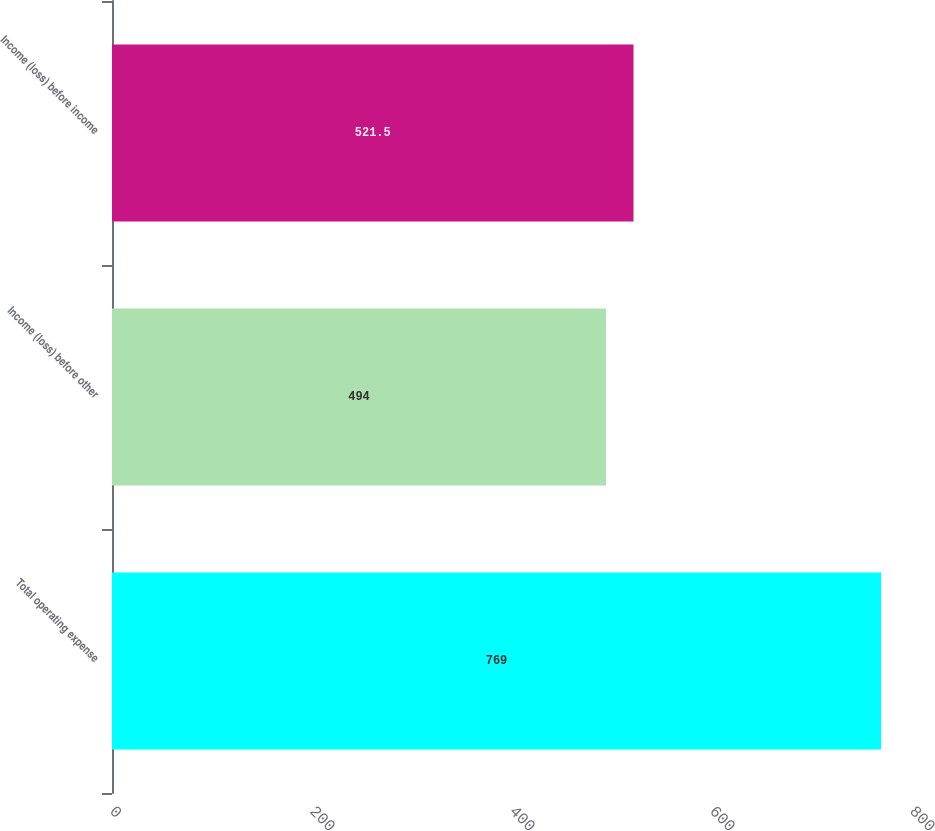<chart> <loc_0><loc_0><loc_500><loc_500><bar_chart><fcel>Total operating expense<fcel>Income (loss) before other<fcel>Income (loss) before income<nl><fcel>769<fcel>494<fcel>521.5<nl></chart> 